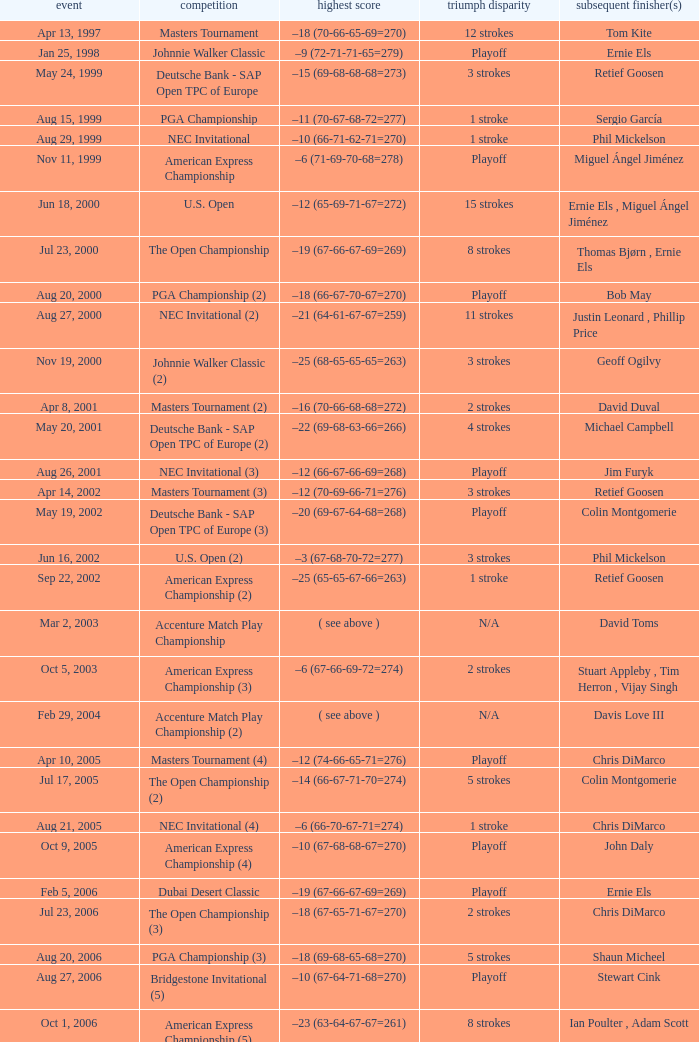Which Tournament has a Margin of victory of 7 strokes Bridgestone Invitational (8). 